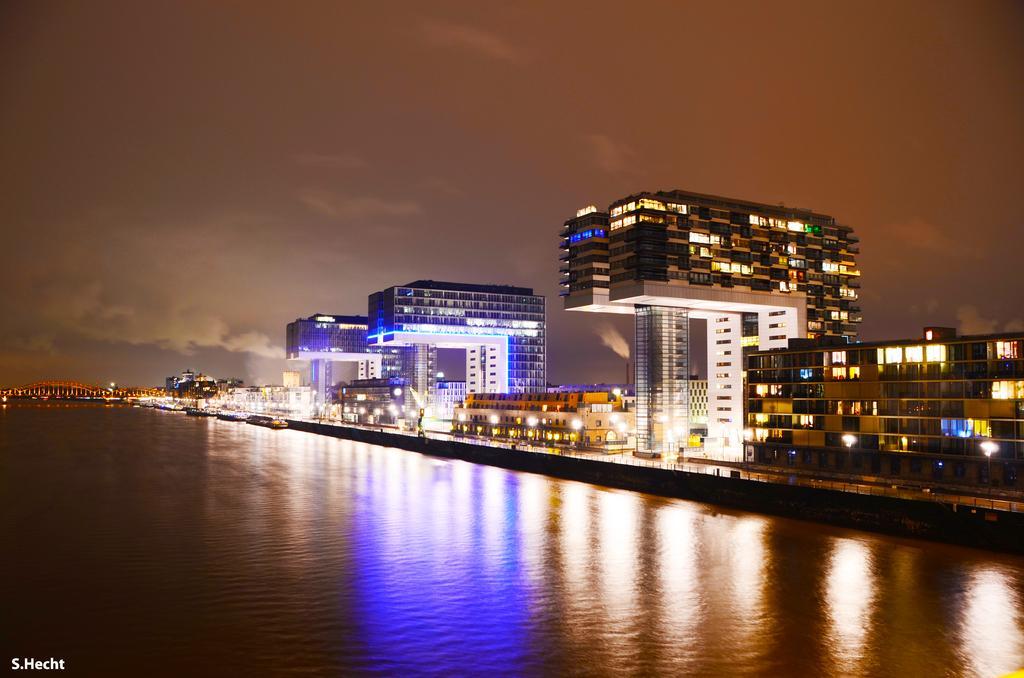How would you summarize this image in a sentence or two? In this image there is a lake, in that lake there are boats, in the background there are buildings, bridge and the sky, on the bottom left there is text. 